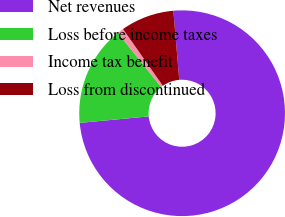<chart> <loc_0><loc_0><loc_500><loc_500><pie_chart><fcel>Net revenues<fcel>Loss before income taxes<fcel>Income tax benefit<fcel>Loss from discontinued<nl><fcel>74.87%<fcel>15.77%<fcel>0.99%<fcel>8.38%<nl></chart> 